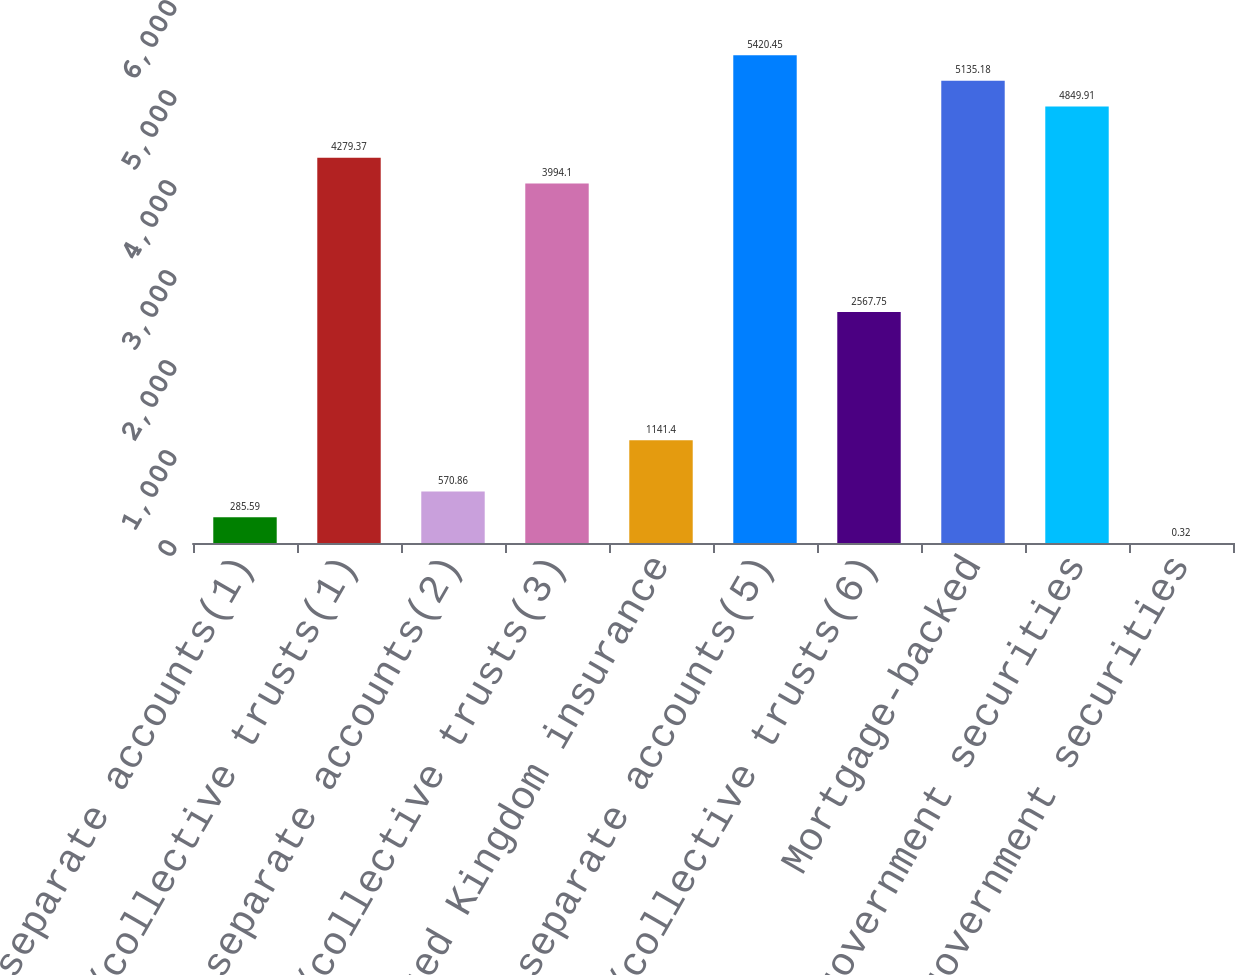Convert chart to OTSL. <chart><loc_0><loc_0><loc_500><loc_500><bar_chart><fcel>Pooled separate accounts(1)<fcel>Common/collective trusts(1)<fcel>Pooled separate accounts(2)<fcel>Common/collective trusts(3)<fcel>United Kingdom insurance<fcel>Pooled separate accounts(5)<fcel>Common/collective trusts(6)<fcel>Mortgage-backed<fcel>Other US government securities<fcel>US government securities<nl><fcel>285.59<fcel>4279.37<fcel>570.86<fcel>3994.1<fcel>1141.4<fcel>5420.45<fcel>2567.75<fcel>5135.18<fcel>4849.91<fcel>0.32<nl></chart> 